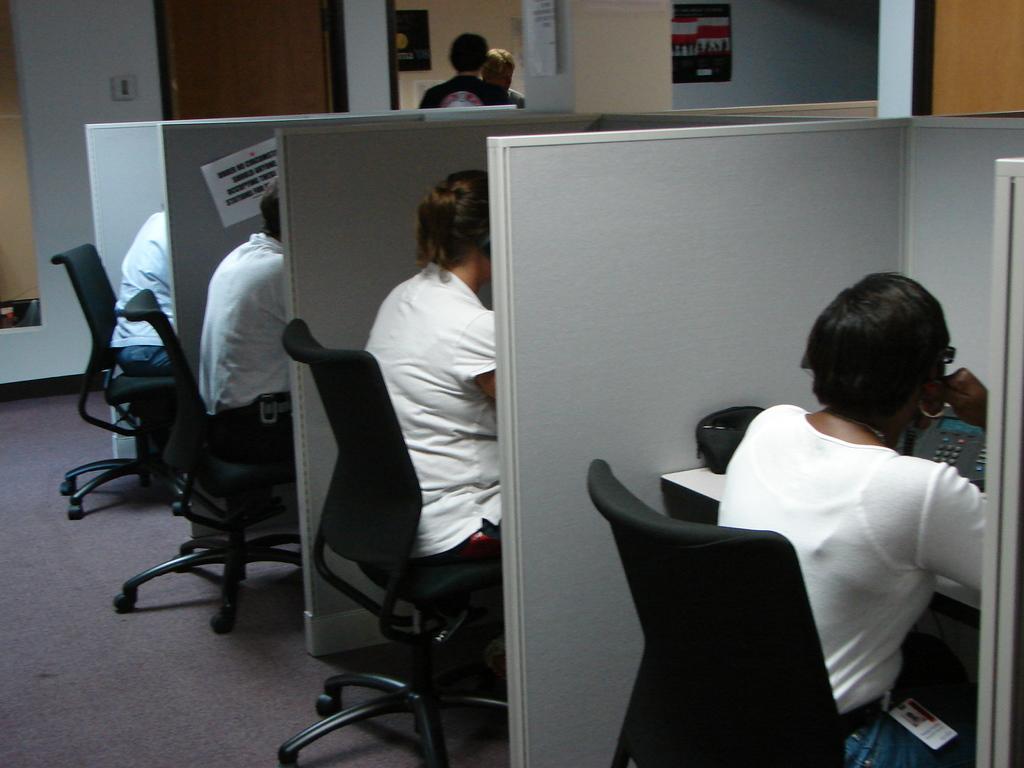How would you summarize this image in a sentence or two? On the background of the picture we can see a wall and two persons standing. these are the boards. Here we can see four cabins and four persons sitting on chairs. This is a floor. this is a paper note. 